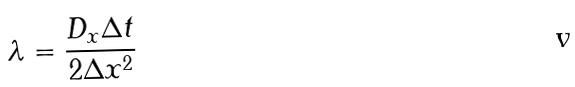Convert formula to latex. <formula><loc_0><loc_0><loc_500><loc_500>\lambda = { \frac { D _ { x } \Delta t } { 2 \Delta x ^ { 2 } } }</formula> 